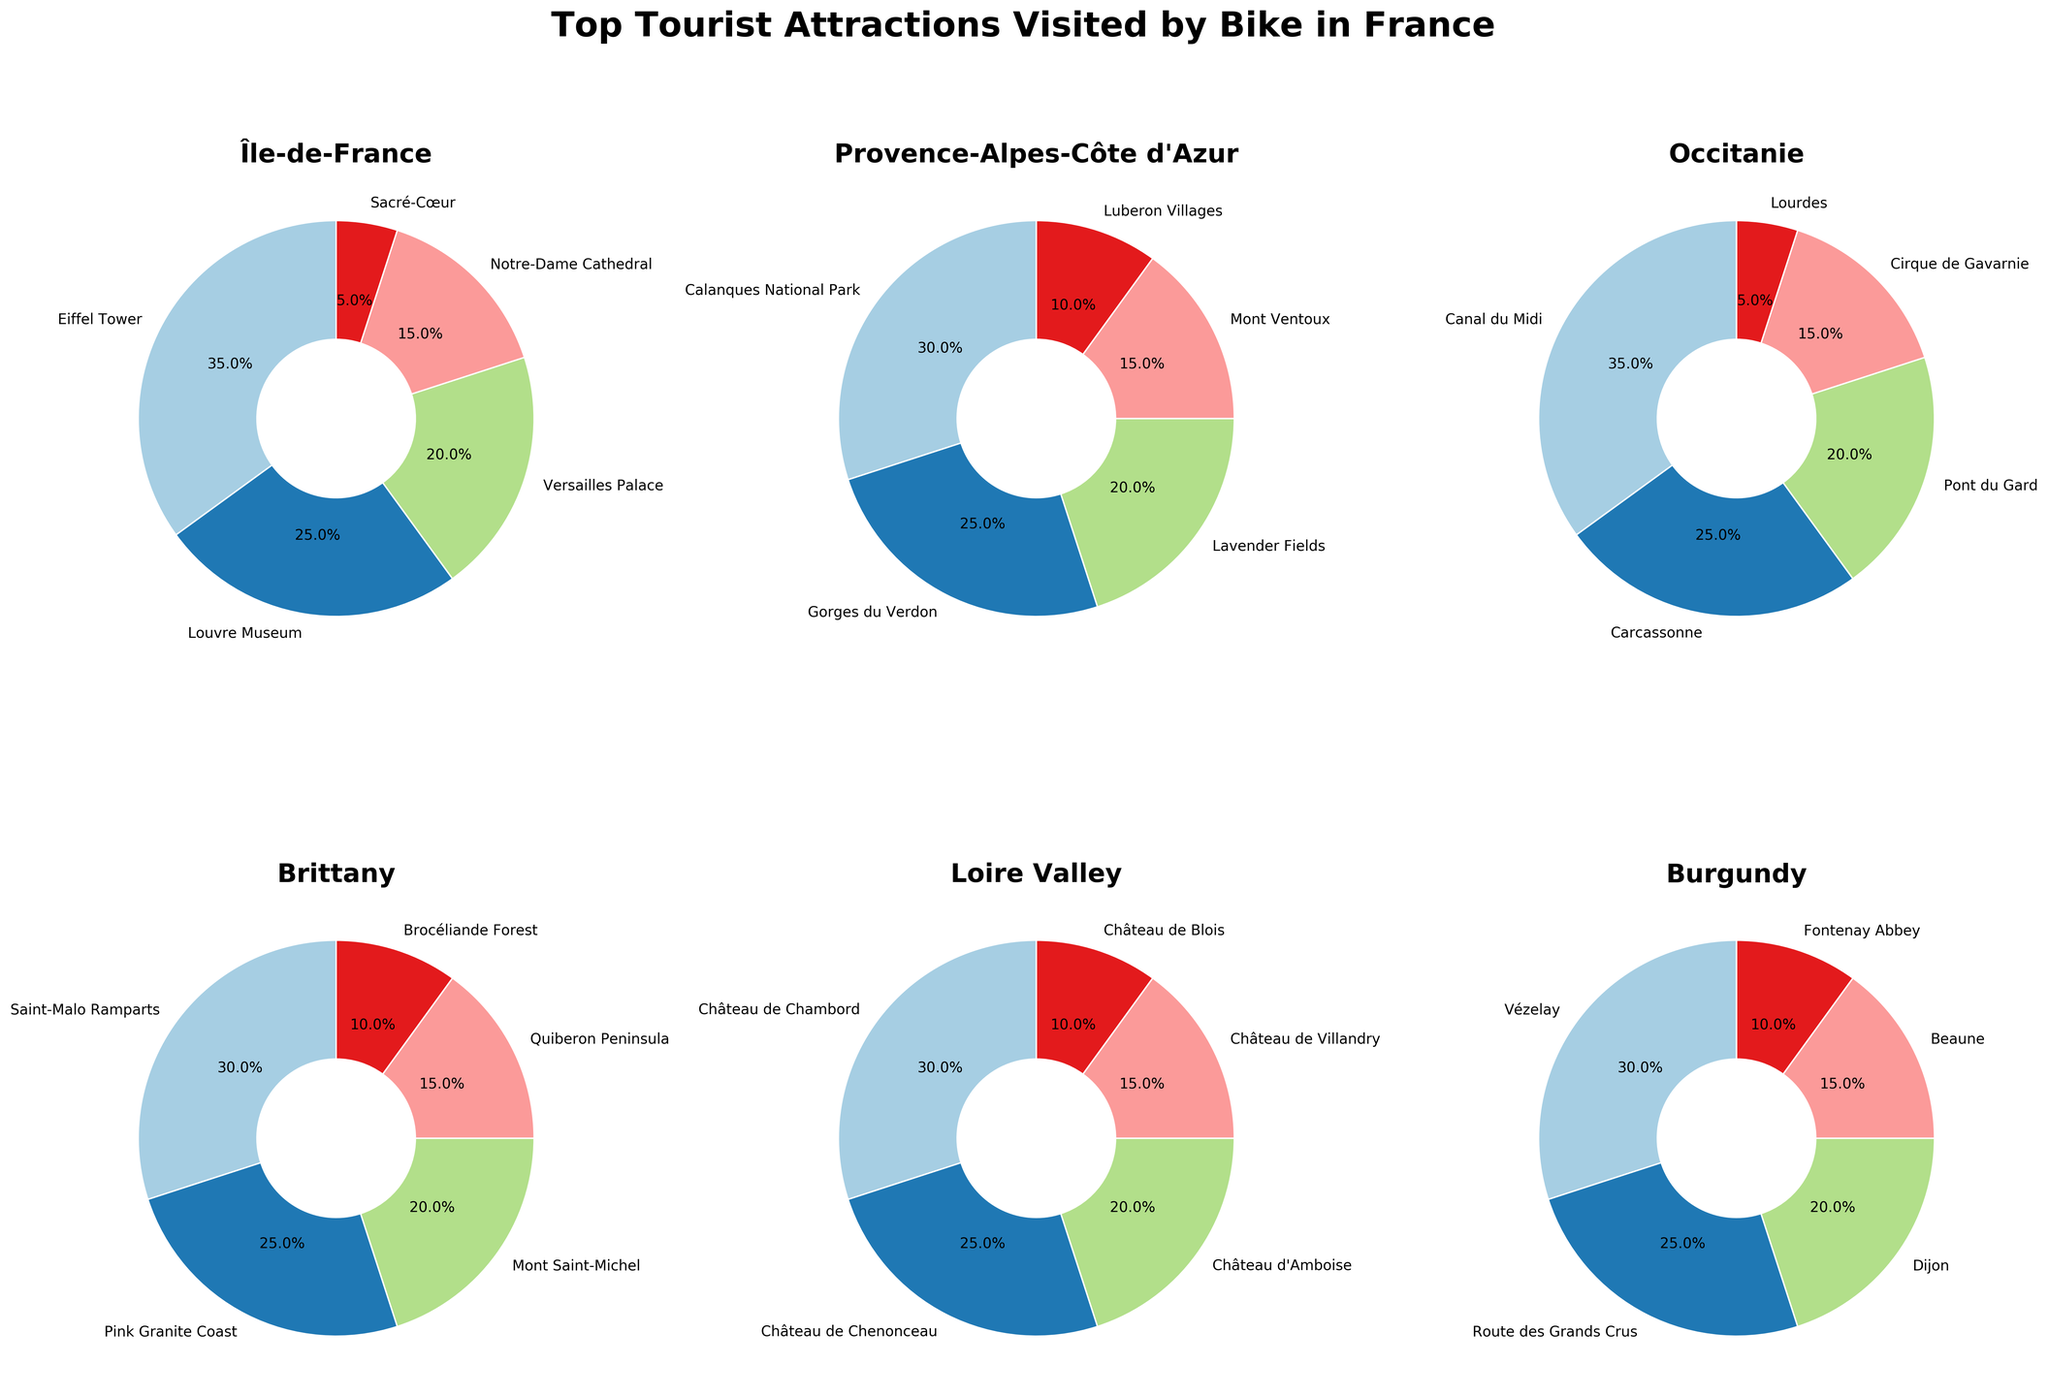Which region has the highest percentage visit for a single attraction? Looking at the pie charts, Île-de-France has the Eiffel Tower with 35%. This is the highest percentage among all attractions in all regions.
Answer: Île-de-France What percentage of tourists visit the Louvre Museum and Versailles Palace combined in Île-de-France? Adding the percentages for the Louvre Museum and Versailles Palace in Île-de-France: 25% + 20% = 45%.
Answer: 45% Which region's top attraction has a larger percentage, Canal du Midi in Occitanie or Calanques National Park in Provence-Alpes-Côte d'Azur? Canal du Midi in Occitanie has 35%, whereas Calanques National Park in Provence-Alpes-Côte d'Azur has 30%. Canal du Midi has a larger percentage.
Answer: Canal du Midi Which attraction in Brittany has the second highest percentage of visitors? In the pie chart for Brittany, the second highest slice is for Pink Granite Coast with 25%.
Answer: Pink Granite Coast How do the combined percentages of attractions in Burgundy compare to those in the Loire Valley? Summing the percentages for Burgundy: 30% + 25% + 20% + 15% + 10% = 100%. For the Loire Valley: 30% + 25% + 20% + 15% + 10% = 100%. Both regions have a total percentage of 100%.
Answer: 100% each Which attraction has the smallest percentage in Île-de-France? In Île-de-France, the smallest pie slice corresponds to Sacré-Cœur with 5%.
Answer: Sacré-Cœur What is the visual difference between the Château de Chambord and Château de Villandry slices in the Loire Valley? The Château de Chambord slice is visibly larger than the Château de Villandry slice, with percentages of 30% and 15% respectively.
Answer: Château de Chambord is larger Compare the total percentage of the top two attractions in Île-de-France and Occitanie. Which region has a higher total? Top two attractions' totals: Île-de-France (Eiffel Tower and Louvre Museum): 35% + 25% = 60%. Occitanie (Canal du Midi and Carcassonne): 35% + 25% = 60%. Both have the same total.
Answer: Both are equal How many attractions in Provence-Alpes-Côte d'Azur have a percentage greater than 20%? In Provence-Alpes-Côte d'Azur, two attractions have percentages greater than 20%: Calanques National Park (30%) and Gorges du Verdon (25%).
Answer: 2 